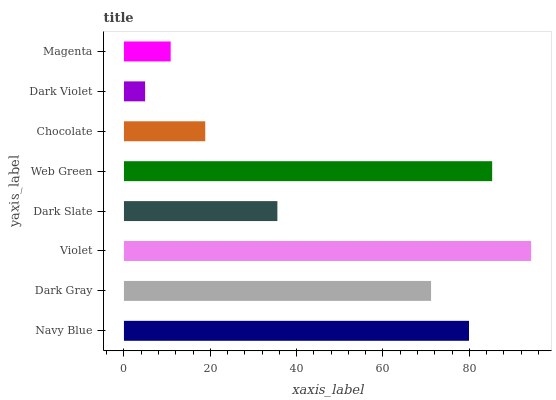Is Dark Violet the minimum?
Answer yes or no. Yes. Is Violet the maximum?
Answer yes or no. Yes. Is Dark Gray the minimum?
Answer yes or no. No. Is Dark Gray the maximum?
Answer yes or no. No. Is Navy Blue greater than Dark Gray?
Answer yes or no. Yes. Is Dark Gray less than Navy Blue?
Answer yes or no. Yes. Is Dark Gray greater than Navy Blue?
Answer yes or no. No. Is Navy Blue less than Dark Gray?
Answer yes or no. No. Is Dark Gray the high median?
Answer yes or no. Yes. Is Dark Slate the low median?
Answer yes or no. Yes. Is Navy Blue the high median?
Answer yes or no. No. Is Magenta the low median?
Answer yes or no. No. 